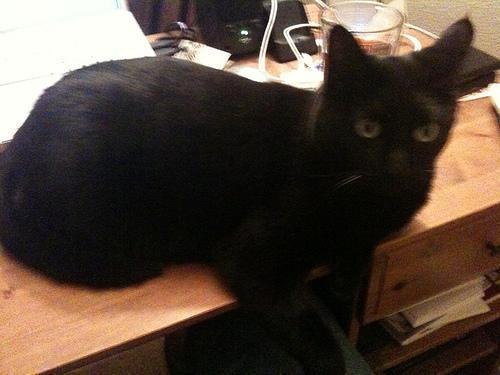What emotion does the cat appear to be expressing?
Indicate the correct response and explain using: 'Answer: answer
Rationale: rationale.'
Options: Disgust, love, excitement, surprise. Answer: surprise.
Rationale: The eyes are very wide open 